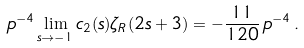Convert formula to latex. <formula><loc_0><loc_0><loc_500><loc_500>p ^ { - 4 } \lim _ { s \to - 1 } c _ { 2 } ( s ) \zeta _ { R } ( 2 s + 3 ) = - \frac { 1 1 } { 1 2 0 } \, p ^ { - 4 } \, .</formula> 